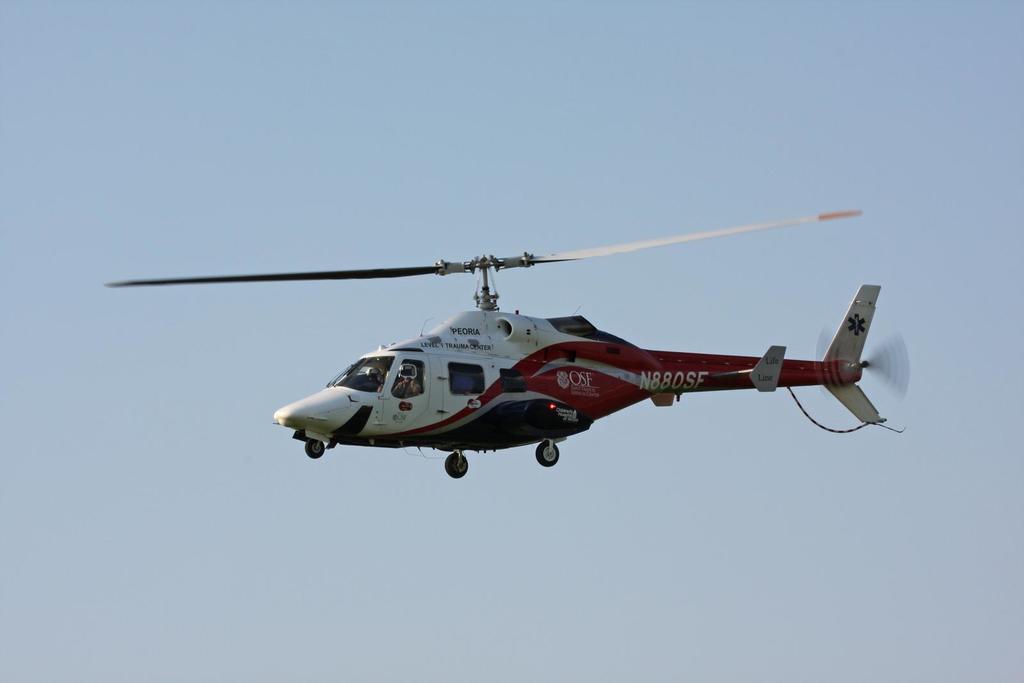Describe this image in one or two sentences. In the foreground of this image, there is a helicopter in the air. In the background, there is the sky. 